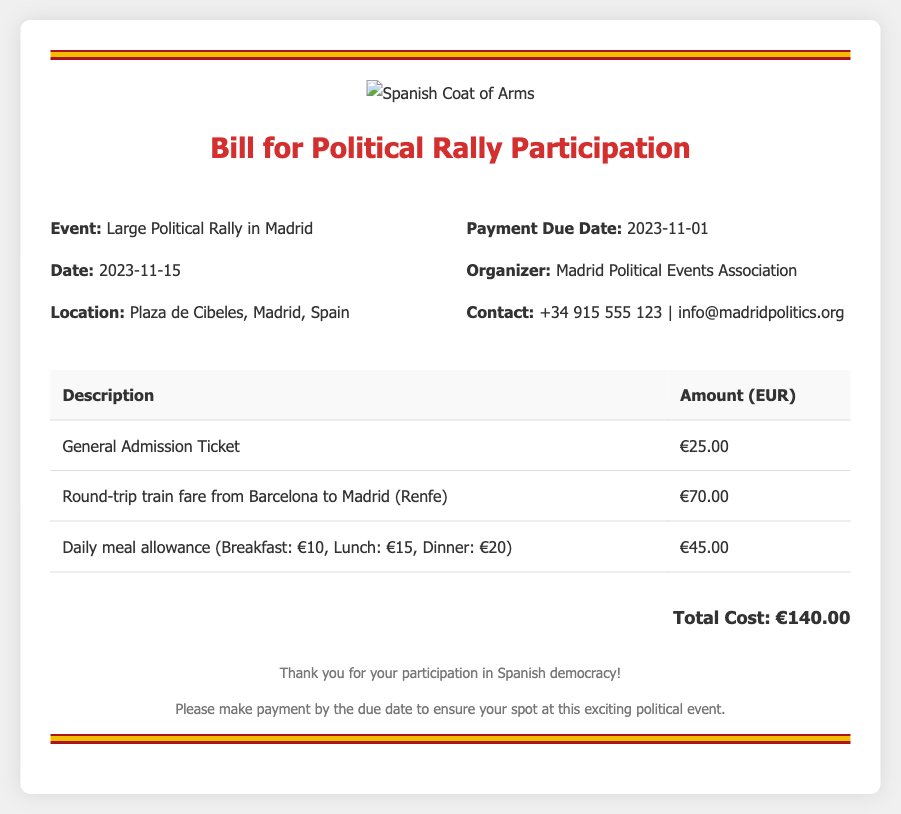What is the price of a general admission ticket? The document states that the general admission ticket costs €25.00.
Answer: €25.00 When is the payment due date? The payment due date mentioned in the document is 2023-11-01.
Answer: 2023-11-01 What is the transportation cost for a round-trip train fare from Barcelona to Madrid? The document specifies that the round-trip train fare is €70.00.
Answer: €70.00 What is the total cost for participating in the rally? The total cost is the sum of all expenses listed, amounting to €140.00.
Answer: €140.00 What is the daily meal allowance total? The document outlines the daily meal costs: Breakfast: €10, Lunch: €15, Dinner: €20, totaling €45.00.
Answer: €45.00 Who is the organizer of the event? The document identifies the organizer as the Madrid Political Events Association.
Answer: Madrid Political Events Association What location is the rally being held at? The location of the rally is stated as Plaza de Cibeles, Madrid, Spain.
Answer: Plaza de Cibeles, Madrid, Spain What is the contact number provided? The document includes the contact number +34 915 555 123.
Answer: +34 915 555 123 On what date will the rally occur? The date of the rally is mentioned as 2023-11-15.
Answer: 2023-11-15 